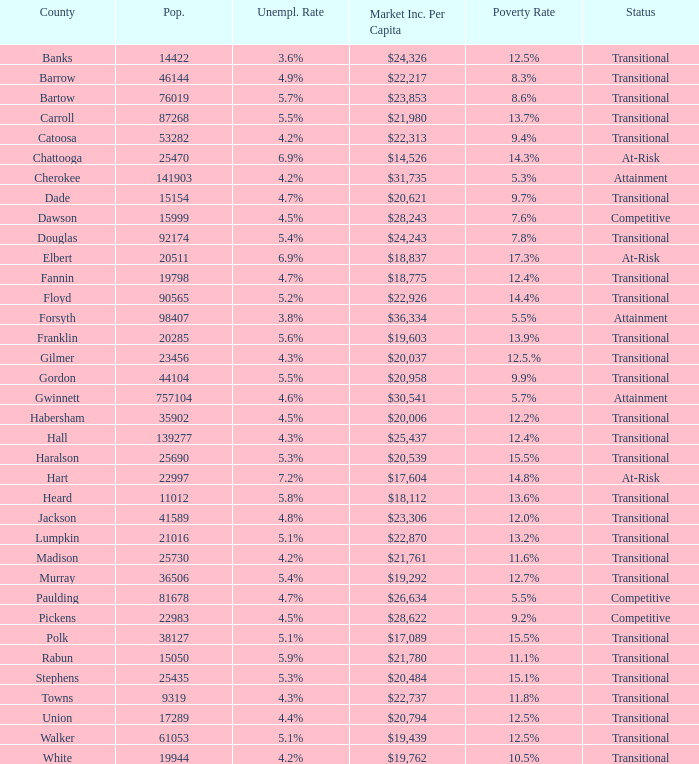What is the status of the county with per capita market income of $24,326? Transitional. 